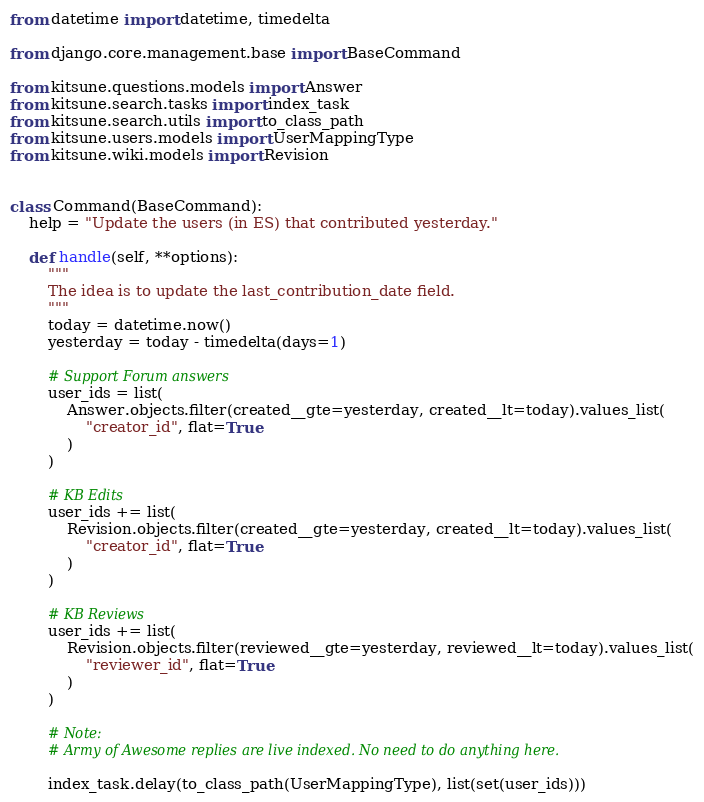Convert code to text. <code><loc_0><loc_0><loc_500><loc_500><_Python_>from datetime import datetime, timedelta

from django.core.management.base import BaseCommand

from kitsune.questions.models import Answer
from kitsune.search.tasks import index_task
from kitsune.search.utils import to_class_path
from kitsune.users.models import UserMappingType
from kitsune.wiki.models import Revision


class Command(BaseCommand):
    help = "Update the users (in ES) that contributed yesterday."

    def handle(self, **options):
        """
        The idea is to update the last_contribution_date field.
        """
        today = datetime.now()
        yesterday = today - timedelta(days=1)

        # Support Forum answers
        user_ids = list(
            Answer.objects.filter(created__gte=yesterday, created__lt=today).values_list(
                "creator_id", flat=True
            )
        )

        # KB Edits
        user_ids += list(
            Revision.objects.filter(created__gte=yesterday, created__lt=today).values_list(
                "creator_id", flat=True
            )
        )

        # KB Reviews
        user_ids += list(
            Revision.objects.filter(reviewed__gte=yesterday, reviewed__lt=today).values_list(
                "reviewer_id", flat=True
            )
        )

        # Note:
        # Army of Awesome replies are live indexed. No need to do anything here.

        index_task.delay(to_class_path(UserMappingType), list(set(user_ids)))
</code> 